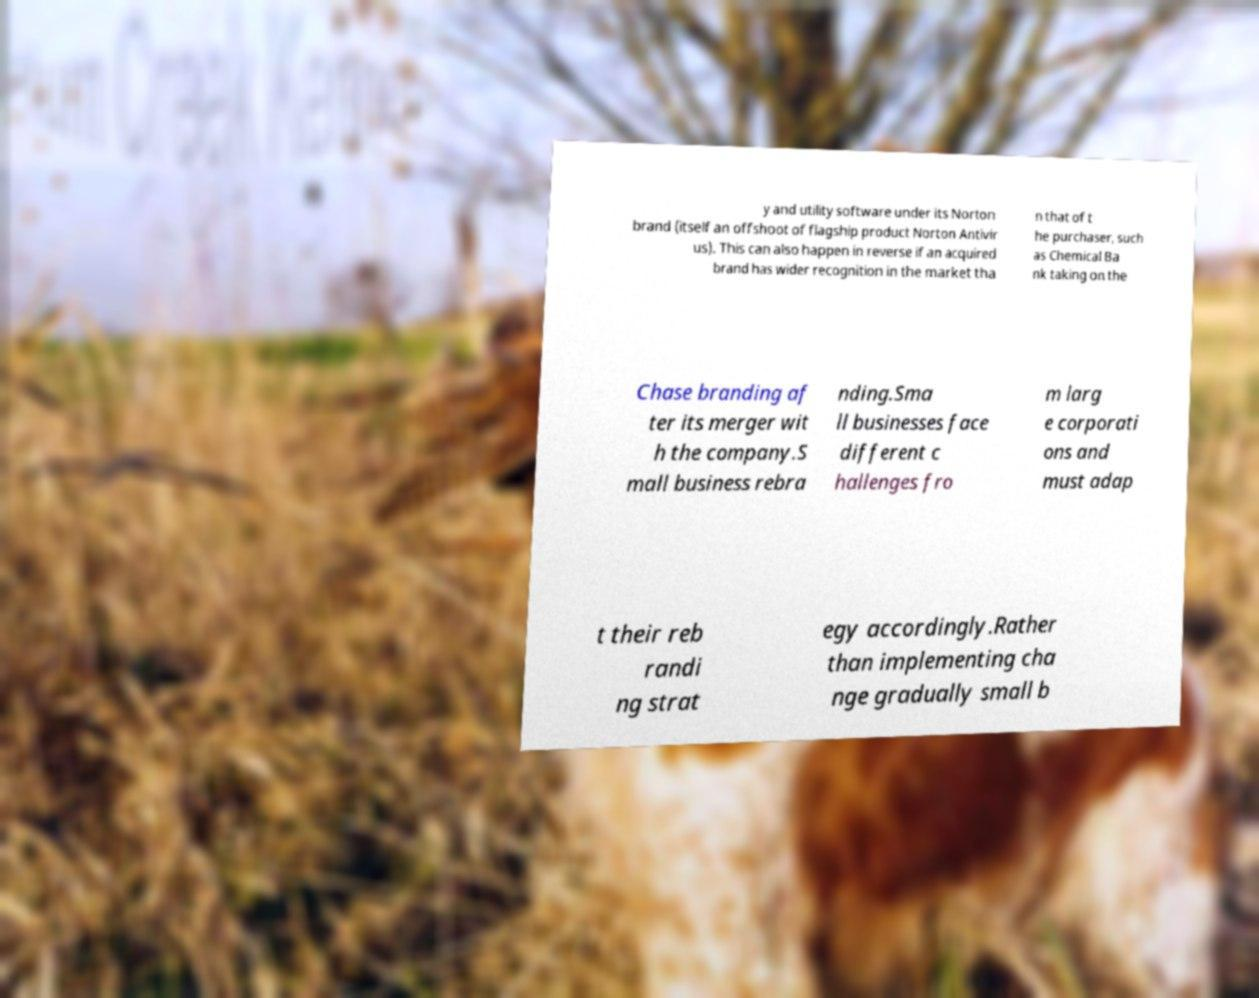Please identify and transcribe the text found in this image. y and utility software under its Norton brand (itself an offshoot of flagship product Norton Antivir us). This can also happen in reverse if an acquired brand has wider recognition in the market tha n that of t he purchaser, such as Chemical Ba nk taking on the Chase branding af ter its merger wit h the company.S mall business rebra nding.Sma ll businesses face different c hallenges fro m larg e corporati ons and must adap t their reb randi ng strat egy accordingly.Rather than implementing cha nge gradually small b 